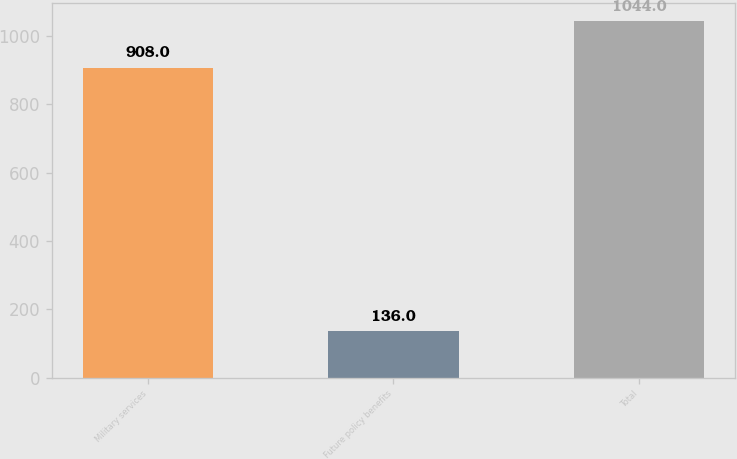Convert chart to OTSL. <chart><loc_0><loc_0><loc_500><loc_500><bar_chart><fcel>Military services<fcel>Future policy benefits<fcel>Total<nl><fcel>908<fcel>136<fcel>1044<nl></chart> 